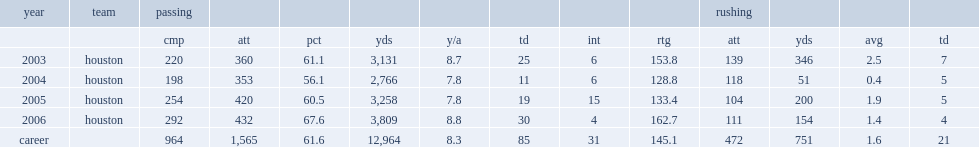What was the total passing yards did kolb end his career with? 12964.0. 